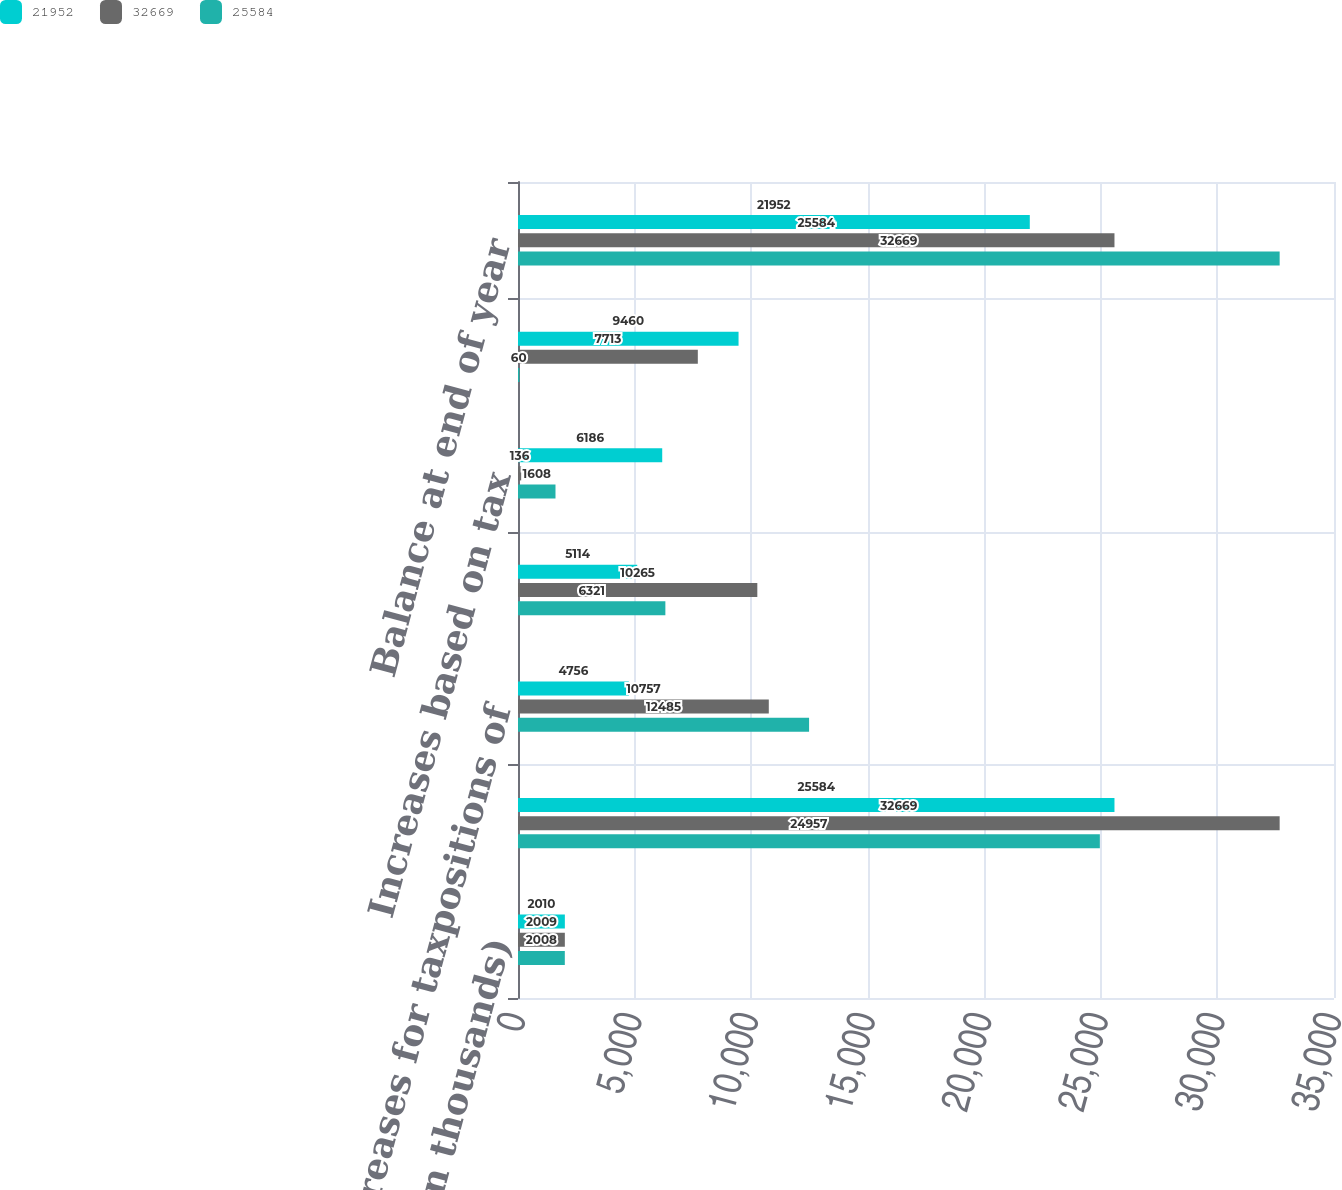Convert chart. <chart><loc_0><loc_0><loc_500><loc_500><stacked_bar_chart><ecel><fcel>(In thousands)<fcel>Balance at beginning of year<fcel>Increases for taxpositions of<fcel>Decreases for tax positions of<fcel>Increases based on tax<fcel>Settlements<fcel>Balance at end of year<nl><fcel>21952<fcel>2010<fcel>25584<fcel>4756<fcel>5114<fcel>6186<fcel>9460<fcel>21952<nl><fcel>32669<fcel>2009<fcel>32669<fcel>10757<fcel>10265<fcel>136<fcel>7713<fcel>25584<nl><fcel>25584<fcel>2008<fcel>24957<fcel>12485<fcel>6321<fcel>1608<fcel>60<fcel>32669<nl></chart> 